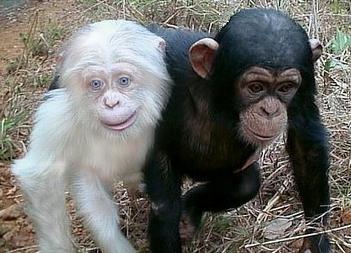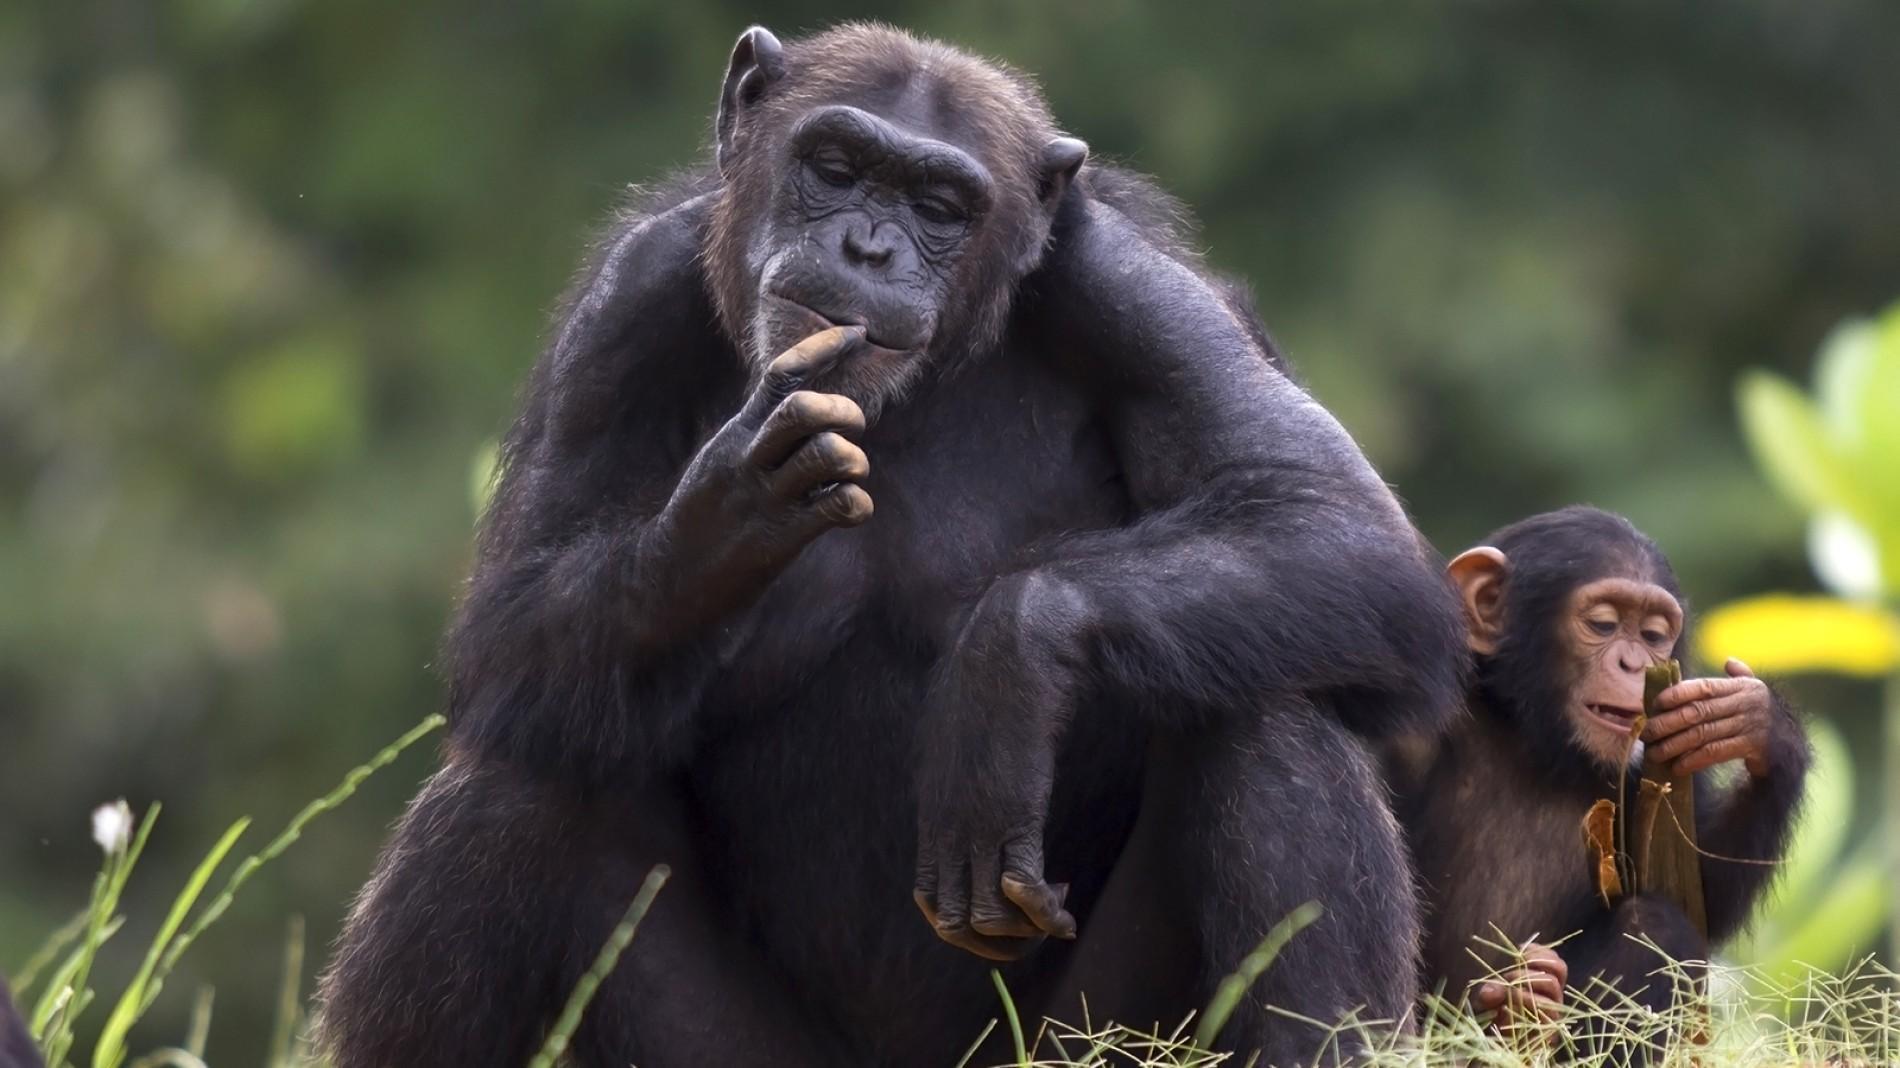The first image is the image on the left, the second image is the image on the right. Examine the images to the left and right. Is the description "An image shows two very similar looking young chimps side by side." accurate? Answer yes or no. No. 